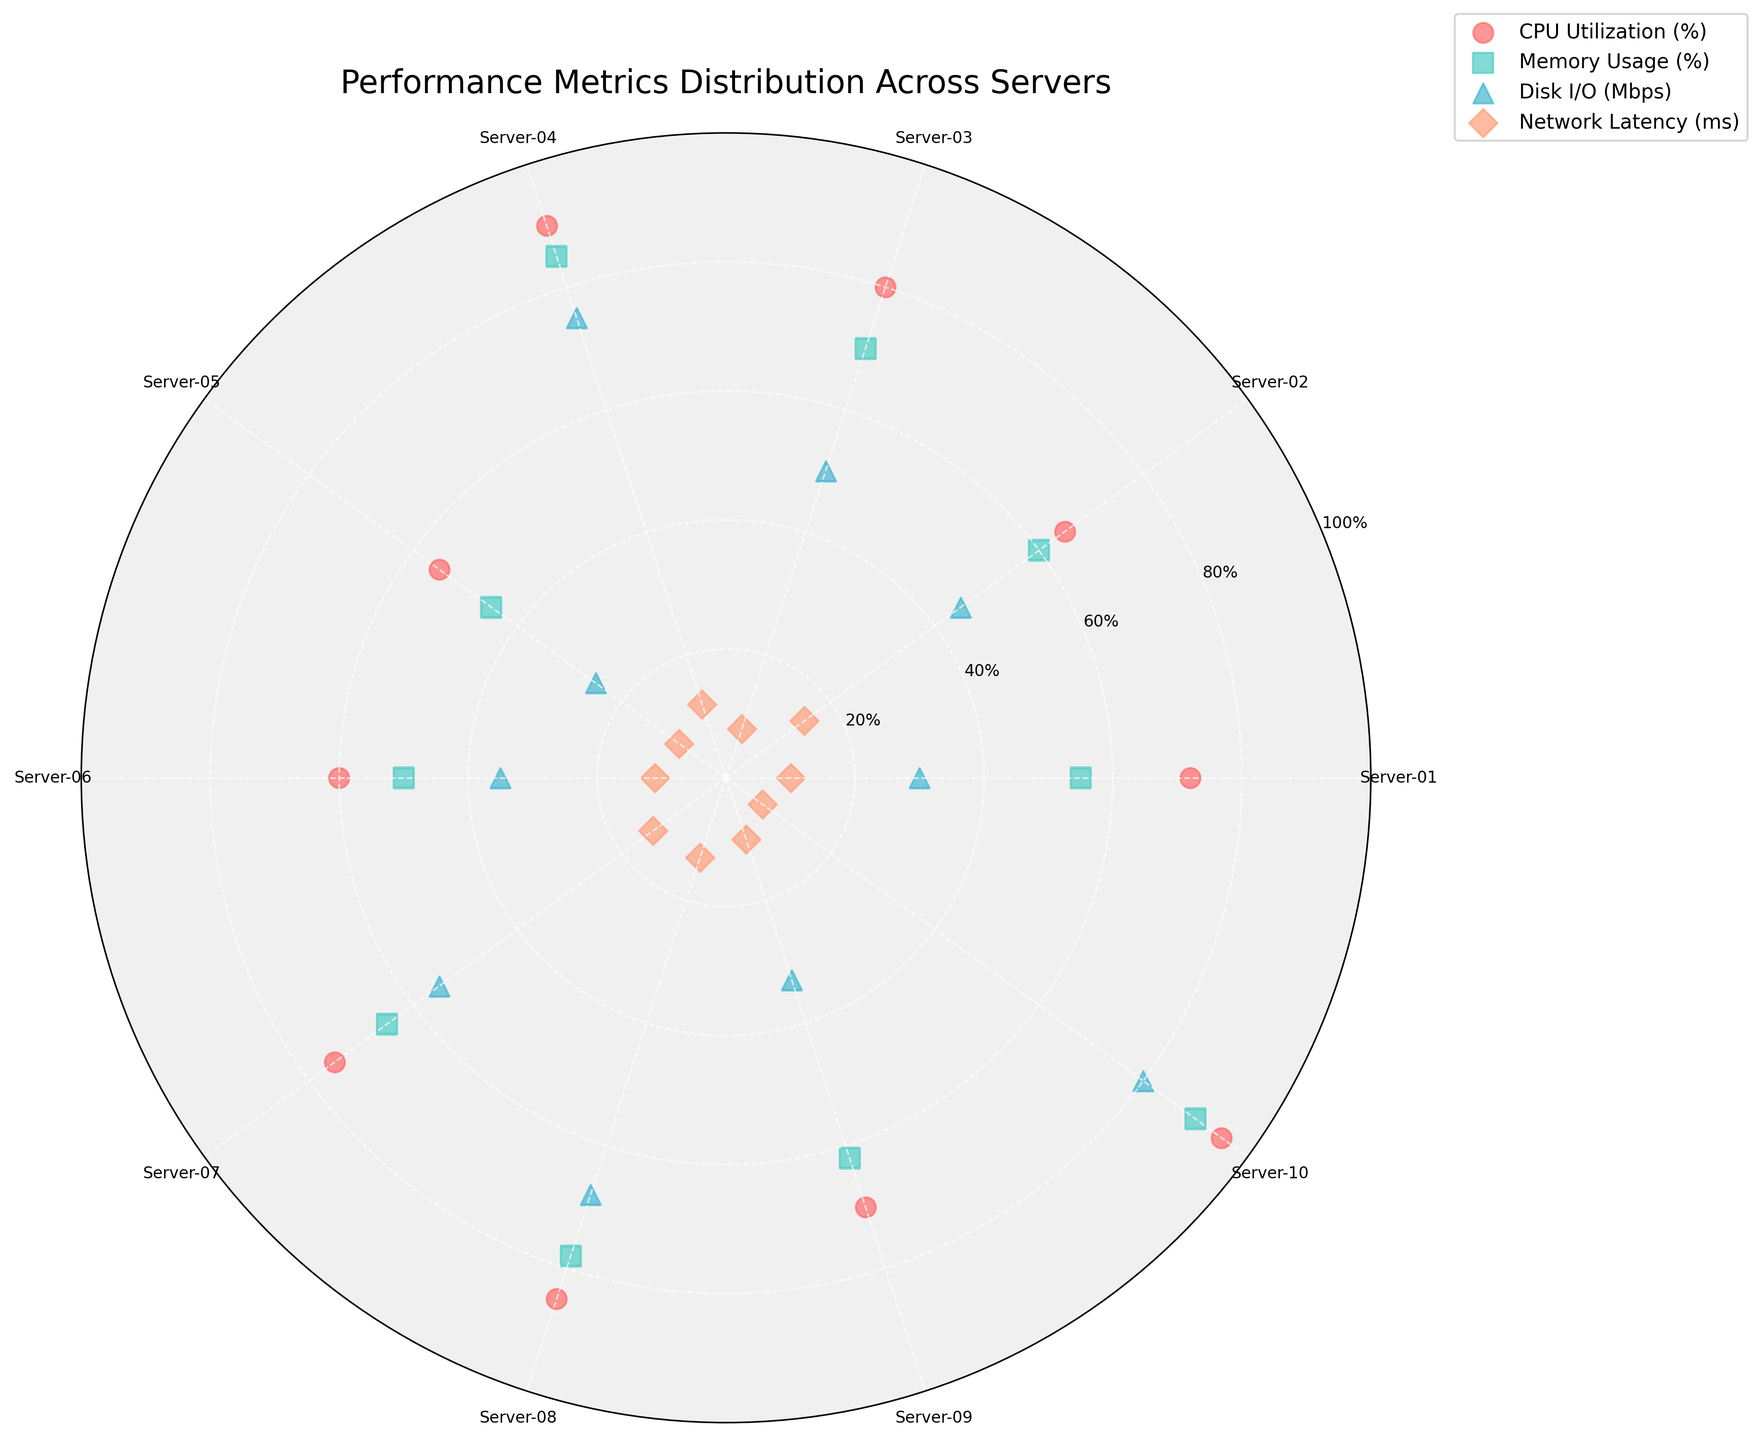What is the title of the figure? The title of the figure is “Performance Metrics Distribution Across Servers”. This title is centered at the top of the chart.
Answer: Performance Metrics Distribution Across Servers Which server shows the highest CPU utilization? In the chart, each server is represented by a different angle. The server with the highest CPU utilization is Server-10, which is marked with the gold marker ('o').
Answer: Server-10 What metric uses the triangular marker on the chart? By looking at the legend, we see that the triangular marker ('^') is used to represent 'Disk I/O (Mbps)'.
Answer: Disk I/O (Mbps) How many servers have a network latency of 10 ms? Observing the chart, 10 ms network latency is represented by angles pointing to Server-01 and Server-09.
Answer: 2 Which server has the highest disk I/O, and what is its value? To find the highest disk I/O, locate the highest point for the triangular markers ('^'). Server-10 has the highest disk I/O at 80 Mbps.
Answer: Server-10, 80 Mbps What is the average CPU utilization (%) across all servers? Sum up the CPU utilization percentages for all servers: (72 + 65 + 80 + 90 + 55 + 60 + 75 + 85 + 70 + 95) = 747. Divide by the number of servers (10), which gives (747 / 10) = 74.7.
Answer: 74.7% Which server has the lowest memory usage, and what is its value? The lowest memory usage can be identified by finding the lowest point among the square markers ('s'). Server-05 has the lowest memory usage at 45%.
Answer: Server-05, 45% Compare the network latency of Server-03 and Server-10. Which one is lower? Locate the network latency of the servers represented by the 'D' markers. Server-10 has 7 ms latency, while Server-03 has 8 ms latency. The latency of Server-10 is lower.
Answer: Server-10 How much more memory usage does Server-04 have compared to Server-06? Check the memory usage percentages for both servers. Server-04 has 85%, and Server-06 has 50%. The difference is (85 - 50) = 35%.
Answer: 35% For which metrics do Server-04 and Server-08 have the same range of utilization? Examining the chart, Server-04 and Server-08 have similar levels for 'Memory Usage (%)' and 'Network Latency (ms)' shown by the same range on the vertical axis.
Answer: Memory Usage (%), Network Latency (ms) 